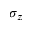Convert formula to latex. <formula><loc_0><loc_0><loc_500><loc_500>\sigma _ { z }</formula> 